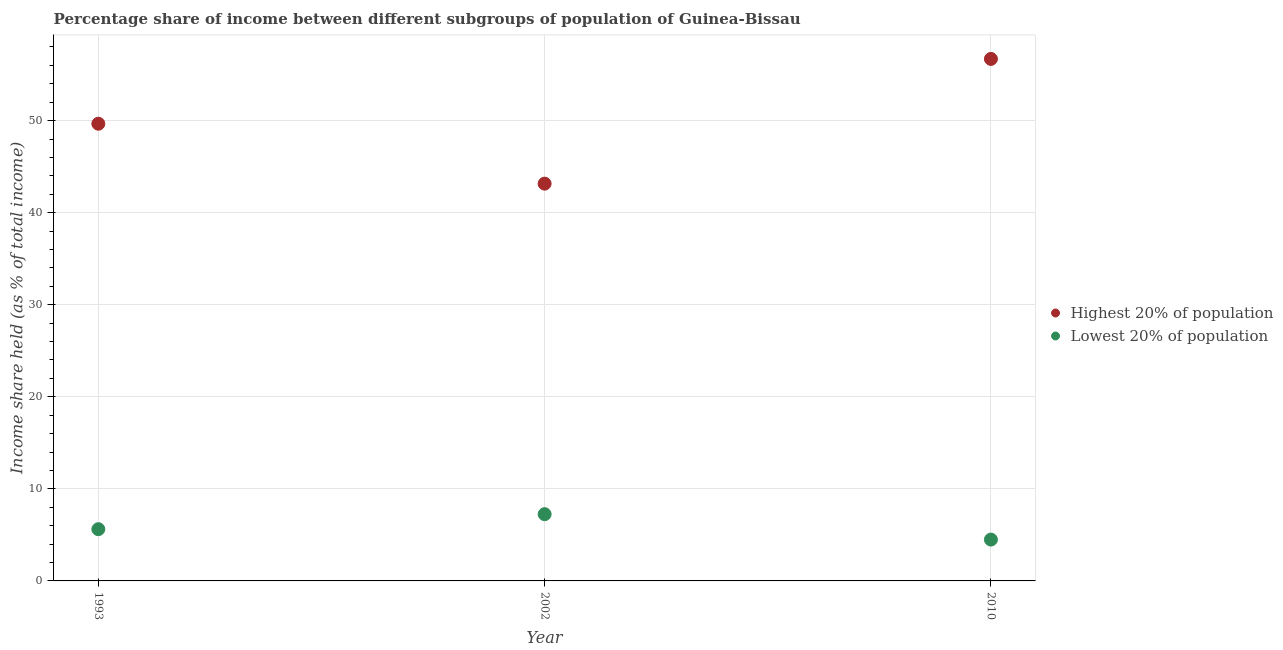How many different coloured dotlines are there?
Make the answer very short. 2. What is the income share held by highest 20% of the population in 1993?
Your answer should be compact. 49.66. Across all years, what is the maximum income share held by lowest 20% of the population?
Give a very brief answer. 7.25. Across all years, what is the minimum income share held by lowest 20% of the population?
Ensure brevity in your answer.  4.49. What is the total income share held by lowest 20% of the population in the graph?
Your answer should be compact. 17.36. What is the difference between the income share held by lowest 20% of the population in 2002 and that in 2010?
Provide a succinct answer. 2.76. What is the difference between the income share held by highest 20% of the population in 1993 and the income share held by lowest 20% of the population in 2002?
Your response must be concise. 42.41. What is the average income share held by highest 20% of the population per year?
Make the answer very short. 49.84. In the year 1993, what is the difference between the income share held by lowest 20% of the population and income share held by highest 20% of the population?
Provide a short and direct response. -44.04. What is the ratio of the income share held by lowest 20% of the population in 1993 to that in 2002?
Your answer should be compact. 0.78. Is the income share held by lowest 20% of the population in 1993 less than that in 2002?
Keep it short and to the point. Yes. Is the difference between the income share held by highest 20% of the population in 2002 and 2010 greater than the difference between the income share held by lowest 20% of the population in 2002 and 2010?
Offer a terse response. No. What is the difference between the highest and the second highest income share held by highest 20% of the population?
Offer a very short reply. 7.04. What is the difference between the highest and the lowest income share held by lowest 20% of the population?
Provide a short and direct response. 2.76. In how many years, is the income share held by highest 20% of the population greater than the average income share held by highest 20% of the population taken over all years?
Give a very brief answer. 1. Is the income share held by lowest 20% of the population strictly greater than the income share held by highest 20% of the population over the years?
Ensure brevity in your answer.  No. Is the income share held by lowest 20% of the population strictly less than the income share held by highest 20% of the population over the years?
Keep it short and to the point. Yes. How many dotlines are there?
Make the answer very short. 2. How many years are there in the graph?
Give a very brief answer. 3. What is the difference between two consecutive major ticks on the Y-axis?
Give a very brief answer. 10. Does the graph contain any zero values?
Give a very brief answer. No. Where does the legend appear in the graph?
Keep it short and to the point. Center right. What is the title of the graph?
Provide a succinct answer. Percentage share of income between different subgroups of population of Guinea-Bissau. What is the label or title of the Y-axis?
Your answer should be very brief. Income share held (as % of total income). What is the Income share held (as % of total income) in Highest 20% of population in 1993?
Provide a succinct answer. 49.66. What is the Income share held (as % of total income) in Lowest 20% of population in 1993?
Make the answer very short. 5.62. What is the Income share held (as % of total income) of Highest 20% of population in 2002?
Your answer should be compact. 43.15. What is the Income share held (as % of total income) of Lowest 20% of population in 2002?
Your answer should be very brief. 7.25. What is the Income share held (as % of total income) in Highest 20% of population in 2010?
Make the answer very short. 56.7. What is the Income share held (as % of total income) of Lowest 20% of population in 2010?
Your response must be concise. 4.49. Across all years, what is the maximum Income share held (as % of total income) of Highest 20% of population?
Make the answer very short. 56.7. Across all years, what is the maximum Income share held (as % of total income) of Lowest 20% of population?
Ensure brevity in your answer.  7.25. Across all years, what is the minimum Income share held (as % of total income) in Highest 20% of population?
Provide a succinct answer. 43.15. Across all years, what is the minimum Income share held (as % of total income) in Lowest 20% of population?
Your answer should be very brief. 4.49. What is the total Income share held (as % of total income) in Highest 20% of population in the graph?
Make the answer very short. 149.51. What is the total Income share held (as % of total income) of Lowest 20% of population in the graph?
Provide a short and direct response. 17.36. What is the difference between the Income share held (as % of total income) in Highest 20% of population in 1993 and that in 2002?
Your response must be concise. 6.51. What is the difference between the Income share held (as % of total income) of Lowest 20% of population in 1993 and that in 2002?
Your answer should be compact. -1.63. What is the difference between the Income share held (as % of total income) in Highest 20% of population in 1993 and that in 2010?
Give a very brief answer. -7.04. What is the difference between the Income share held (as % of total income) of Lowest 20% of population in 1993 and that in 2010?
Ensure brevity in your answer.  1.13. What is the difference between the Income share held (as % of total income) in Highest 20% of population in 2002 and that in 2010?
Your answer should be very brief. -13.55. What is the difference between the Income share held (as % of total income) in Lowest 20% of population in 2002 and that in 2010?
Offer a very short reply. 2.76. What is the difference between the Income share held (as % of total income) of Highest 20% of population in 1993 and the Income share held (as % of total income) of Lowest 20% of population in 2002?
Provide a short and direct response. 42.41. What is the difference between the Income share held (as % of total income) of Highest 20% of population in 1993 and the Income share held (as % of total income) of Lowest 20% of population in 2010?
Ensure brevity in your answer.  45.17. What is the difference between the Income share held (as % of total income) of Highest 20% of population in 2002 and the Income share held (as % of total income) of Lowest 20% of population in 2010?
Keep it short and to the point. 38.66. What is the average Income share held (as % of total income) in Highest 20% of population per year?
Offer a very short reply. 49.84. What is the average Income share held (as % of total income) in Lowest 20% of population per year?
Make the answer very short. 5.79. In the year 1993, what is the difference between the Income share held (as % of total income) of Highest 20% of population and Income share held (as % of total income) of Lowest 20% of population?
Your answer should be very brief. 44.04. In the year 2002, what is the difference between the Income share held (as % of total income) in Highest 20% of population and Income share held (as % of total income) in Lowest 20% of population?
Offer a terse response. 35.9. In the year 2010, what is the difference between the Income share held (as % of total income) in Highest 20% of population and Income share held (as % of total income) in Lowest 20% of population?
Give a very brief answer. 52.21. What is the ratio of the Income share held (as % of total income) of Highest 20% of population in 1993 to that in 2002?
Your response must be concise. 1.15. What is the ratio of the Income share held (as % of total income) in Lowest 20% of population in 1993 to that in 2002?
Provide a short and direct response. 0.78. What is the ratio of the Income share held (as % of total income) in Highest 20% of population in 1993 to that in 2010?
Your answer should be compact. 0.88. What is the ratio of the Income share held (as % of total income) of Lowest 20% of population in 1993 to that in 2010?
Ensure brevity in your answer.  1.25. What is the ratio of the Income share held (as % of total income) of Highest 20% of population in 2002 to that in 2010?
Provide a short and direct response. 0.76. What is the ratio of the Income share held (as % of total income) in Lowest 20% of population in 2002 to that in 2010?
Your answer should be very brief. 1.61. What is the difference between the highest and the second highest Income share held (as % of total income) in Highest 20% of population?
Provide a short and direct response. 7.04. What is the difference between the highest and the second highest Income share held (as % of total income) in Lowest 20% of population?
Your answer should be compact. 1.63. What is the difference between the highest and the lowest Income share held (as % of total income) in Highest 20% of population?
Your answer should be compact. 13.55. What is the difference between the highest and the lowest Income share held (as % of total income) in Lowest 20% of population?
Offer a very short reply. 2.76. 